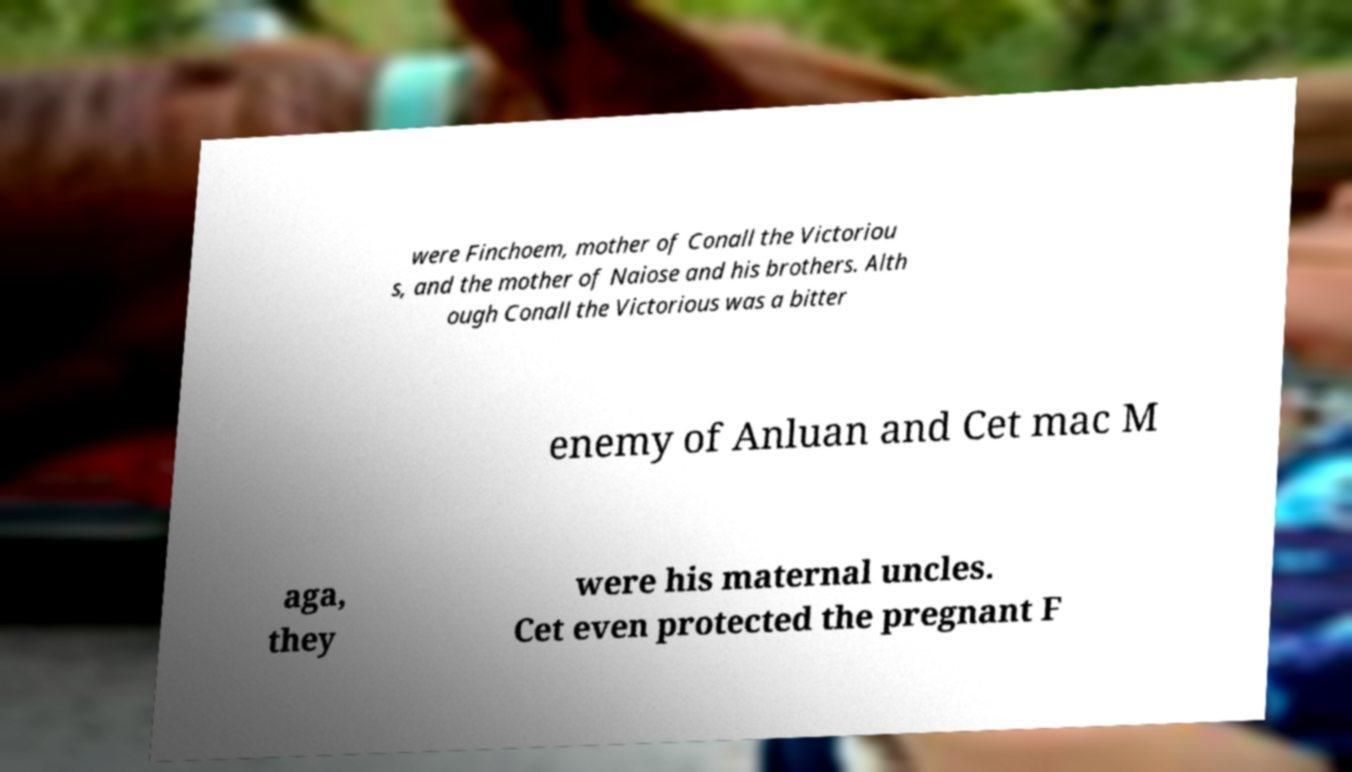What messages or text are displayed in this image? I need them in a readable, typed format. were Finchoem, mother of Conall the Victoriou s, and the mother of Naiose and his brothers. Alth ough Conall the Victorious was a bitter enemy of Anluan and Cet mac M aga, they were his maternal uncles. Cet even protected the pregnant F 